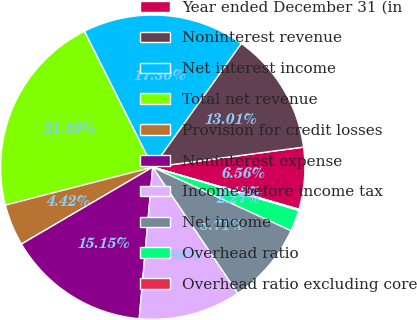Convert chart to OTSL. <chart><loc_0><loc_0><loc_500><loc_500><pie_chart><fcel>Year ended December 31 (in<fcel>Noninterest revenue<fcel>Net interest income<fcel>Total net revenue<fcel>Provision for credit losses<fcel>Noninterest expense<fcel>Income before income tax<fcel>Net income<fcel>Overhead ratio<fcel>Overhead ratio excluding core<nl><fcel>6.56%<fcel>13.01%<fcel>17.3%<fcel>21.59%<fcel>4.42%<fcel>15.15%<fcel>10.86%<fcel>8.71%<fcel>2.27%<fcel>0.12%<nl></chart> 